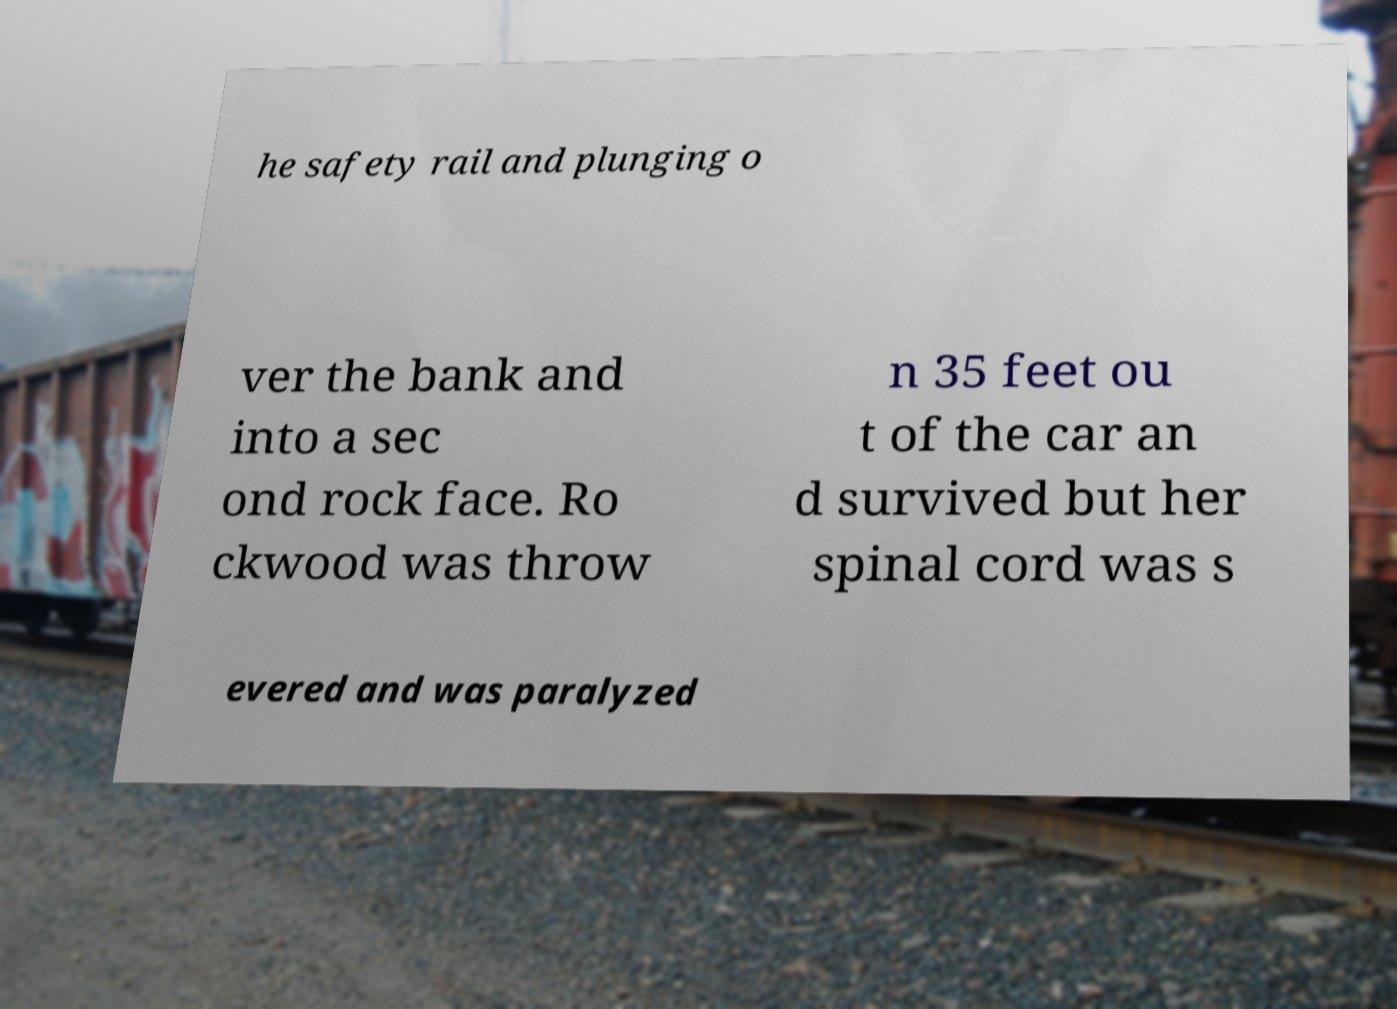Can you read and provide the text displayed in the image?This photo seems to have some interesting text. Can you extract and type it out for me? he safety rail and plunging o ver the bank and into a sec ond rock face. Ro ckwood was throw n 35 feet ou t of the car an d survived but her spinal cord was s evered and was paralyzed 